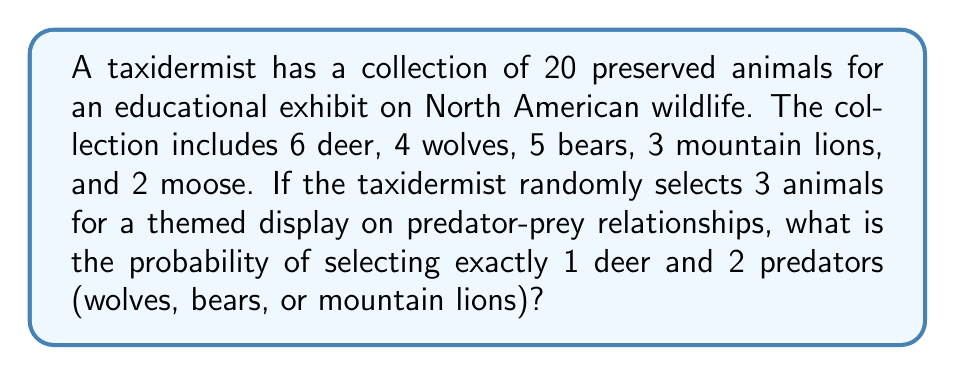Teach me how to tackle this problem. Let's approach this step-by-step:

1) First, we need to calculate the total number of ways to select 3 animals out of 20. This is given by the combination formula:

   $$\binom{20}{3} = \frac{20!}{3!(20-3)!} = \frac{20!}{3!17!} = 1140$$

2) Now, we need to calculate the number of favorable outcomes. This can be done by:
   a) Selecting 1 deer out of 6
   b) Selecting 2 predators out of 12 (4 wolves + 5 bears + 3 mountain lions)

3) The number of ways to select 1 deer out of 6:

   $$\binom{6}{1} = 6$$

4) The number of ways to select 2 predators out of 12:

   $$\binom{12}{2} = \frac{12!}{2!10!} = 66$$

5) By the multiplication principle, the total number of favorable outcomes is:

   $$6 \times 66 = 396$$

6) The probability is then the number of favorable outcomes divided by the total number of possible outcomes:

   $$P(\text{1 deer and 2 predators}) = \frac{396}{1140} = \frac{33}{95} \approx 0.3474$$
Answer: $\frac{33}{95}$ or approximately 0.3474 (34.74%) 